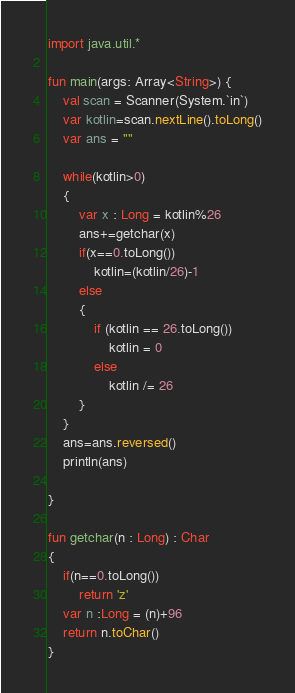Convert code to text. <code><loc_0><loc_0><loc_500><loc_500><_Kotlin_>import java.util.*

fun main(args: Array<String>) {
    val scan = Scanner(System.`in`)
    var kotlin=scan.nextLine().toLong()
    var ans = ""

    while(kotlin>0)
    {
        var x : Long = kotlin%26
        ans+=getchar(x)
        if(x==0.toLong())
            kotlin=(kotlin/26)-1
        else
        {
            if (kotlin == 26.toLong())
                kotlin = 0
            else
                kotlin /= 26
        }
    }
    ans=ans.reversed()
    println(ans)

}

fun getchar(n : Long) : Char
{
    if(n==0.toLong())
        return 'z'
    var n :Long = (n)+96
    return n.toChar()
}
</code> 